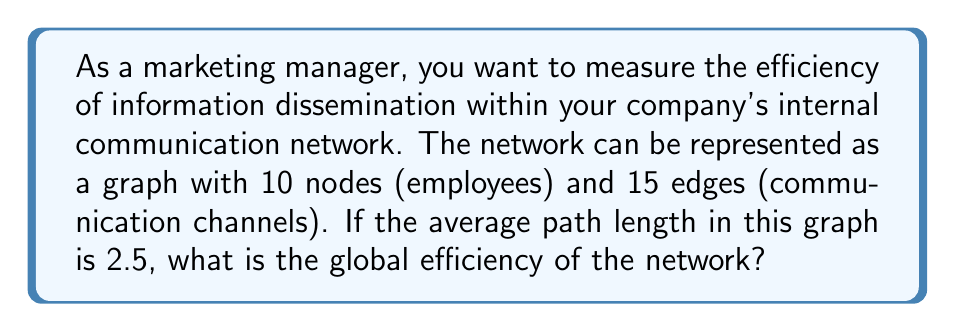Could you help me with this problem? To solve this problem, we'll use the concept of global efficiency in graph theory. The steps are as follows:

1) Global efficiency is defined as the average of the inverse shortest path lengths between all pairs of nodes. It's given by the formula:

   $$E = \frac{1}{n(n-1)} \sum_{i \neq j} \frac{1}{d_{ij}}$$

   Where:
   $E$ is the global efficiency
   $n$ is the number of nodes
   $d_{ij}$ is the shortest path length between nodes $i$ and $j$

2) We're given that:
   - Number of nodes, $n = 10$
   - Average path length, $\bar{d} = 2.5$

3) The sum of all path lengths can be calculated as:
   $$\sum_{i \neq j} d_{ij} = \bar{d} \cdot n(n-1) = 2.5 \cdot 10 \cdot 9 = 225$$

4) Now, we need to find $\sum_{i \neq j} \frac{1}{d_{ij}}$. We can use the harmonic mean relationship:

   $$\frac{n(n-1)}{\sum_{i \neq j} \frac{1}{d_{ij}}} = \frac{\sum_{i \neq j} d_{ij}}{n(n-1)}$$

5) Substituting the values:

   $$\frac{90}{\sum_{i \neq j} \frac{1}{d_{ij}}} = \frac{225}{90}$$

6) Solving for $\sum_{i \neq j} \frac{1}{d_{ij}}$:

   $$\sum_{i \neq j} \frac{1}{d_{ij}} = \frac{90^2}{225} = 36$$

7) Finally, we can calculate the global efficiency:

   $$E = \frac{1}{n(n-1)} \sum_{i \neq j} \frac{1}{d_{ij}} = \frac{1}{90} \cdot 36 = 0.4$$

Therefore, the global efficiency of the network is 0.4.
Answer: 0.4 